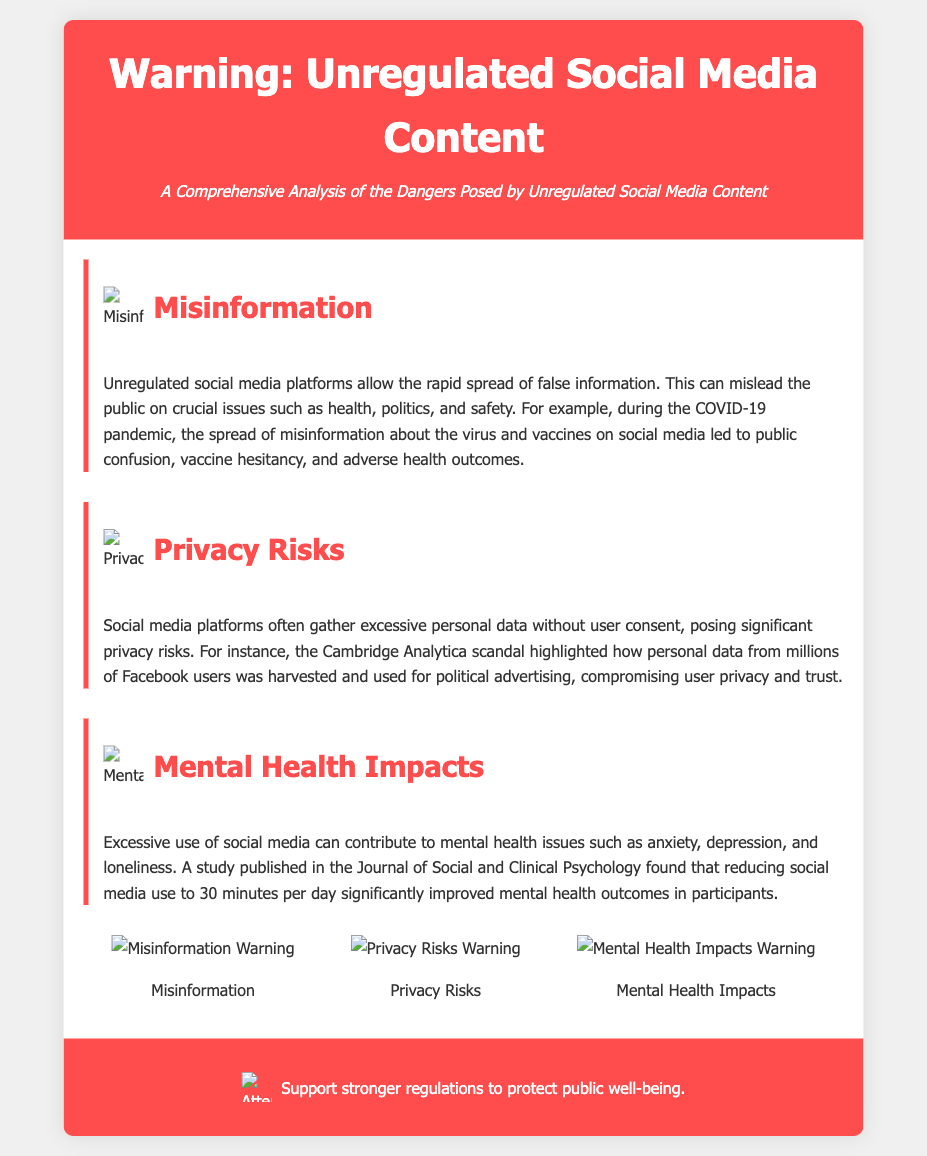What is the title of the document? The title is explicitly stated in the header of the document.
Answer: Warning: Unregulated Social Media Content What are the three main sections addressed? The sections are clearly labeled in the document, summarizing the key issues.
Answer: Misinformation, Privacy Risks, Mental Health Impacts Which scandal is mentioned regarding privacy risks? The document specifically references a well-known event to illustrate privacy issues.
Answer: Cambridge Analytica scandal How does excessive social media use affect mental health? The impact is discussed based on findings from a specific study cited in the document.
Answer: Contributes to anxiety, depression, and loneliness What visual elements accompany each section? The document includes icons to aid in quick visualization of each main section.
Answer: Icons What is the call to action at the end of the document? The last section summarizes the intended action for the reader to take concerning regulations.
Answer: Support stronger regulations to protect public well-being During which pandemic was misinformation notably spread according to the document? A specific context is provided to exemplify the problem of misinformation.
Answer: COVID-19 What was the effect of reducing social media use to 30 minutes per day? The document cites an outcome from research to highlight a potential solution.
Answer: Improved mental health outcomes 